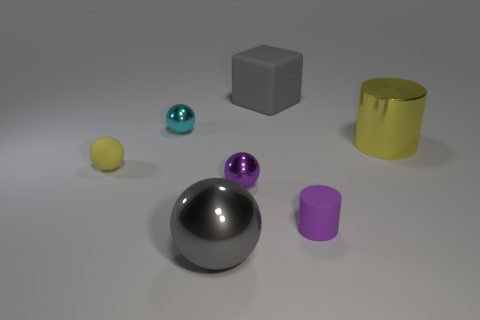Are there any other things that are the same shape as the big gray rubber thing?
Make the answer very short. No. What shape is the tiny rubber thing that is the same color as the shiny cylinder?
Make the answer very short. Sphere. The yellow cylinder that is made of the same material as the cyan sphere is what size?
Your answer should be compact. Large. Do the gray shiny object and the cylinder behind the purple metal object have the same size?
Make the answer very short. Yes. There is a large gray object that is behind the large yellow metallic thing; what is it made of?
Your response must be concise. Rubber. What number of large cubes are behind the yellow object in front of the big metallic cylinder?
Your answer should be very brief. 1. Are there any other shiny things that have the same shape as the tiny cyan metallic thing?
Your answer should be very brief. Yes. Is the size of the gray thing that is in front of the purple matte cylinder the same as the metal ball that is behind the yellow metal cylinder?
Provide a short and direct response. No. The yellow thing that is right of the big gray object that is behind the large yellow thing is what shape?
Keep it short and to the point. Cylinder. What number of blue matte objects are the same size as the purple metallic object?
Your answer should be very brief. 0. 